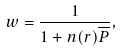Convert formula to latex. <formula><loc_0><loc_0><loc_500><loc_500>w = \frac { 1 } { 1 + n ( { r } ) \overline { P } } ,</formula> 